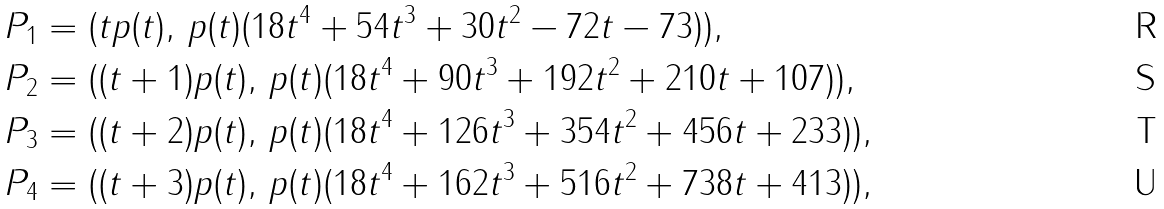Convert formula to latex. <formula><loc_0><loc_0><loc_500><loc_500>& P _ { 1 } = ( t p ( t ) , \, p ( t ) ( 1 8 t ^ { 4 } + 5 4 t ^ { 3 } + 3 0 t ^ { 2 } - 7 2 t - 7 3 ) ) , \\ & P _ { 2 } = ( ( t + 1 ) p ( t ) , \, p ( t ) ( 1 8 t ^ { 4 } + 9 0 t ^ { 3 } + 1 9 2 t ^ { 2 } + 2 1 0 t + 1 0 7 ) ) , \\ & P _ { 3 } = ( ( t + 2 ) p ( t ) , \, p ( t ) ( 1 8 t ^ { 4 } + 1 2 6 t ^ { 3 } + 3 5 4 t ^ { 2 } + 4 5 6 t + 2 3 3 ) ) , \\ & P _ { 4 } = ( ( t + 3 ) p ( t ) , \, p ( t ) ( 1 8 t ^ { 4 } + 1 6 2 t ^ { 3 } + 5 1 6 t ^ { 2 } + 7 3 8 t + 4 1 3 ) ) ,</formula> 